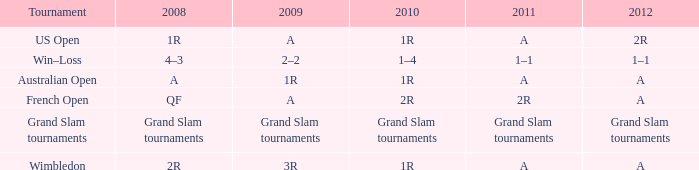Name the 2010 for 2011 of a and 2008 of 1r 1R. Parse the table in full. {'header': ['Tournament', '2008', '2009', '2010', '2011', '2012'], 'rows': [['US Open', '1R', 'A', '1R', 'A', '2R'], ['Win–Loss', '4–3', '2–2', '1–4', '1–1', '1–1'], ['Australian Open', 'A', '1R', '1R', 'A', 'A'], ['French Open', 'QF', 'A', '2R', '2R', 'A'], ['Grand Slam tournaments', 'Grand Slam tournaments', 'Grand Slam tournaments', 'Grand Slam tournaments', 'Grand Slam tournaments', 'Grand Slam tournaments'], ['Wimbledon', '2R', '3R', '1R', 'A', 'A']]} 